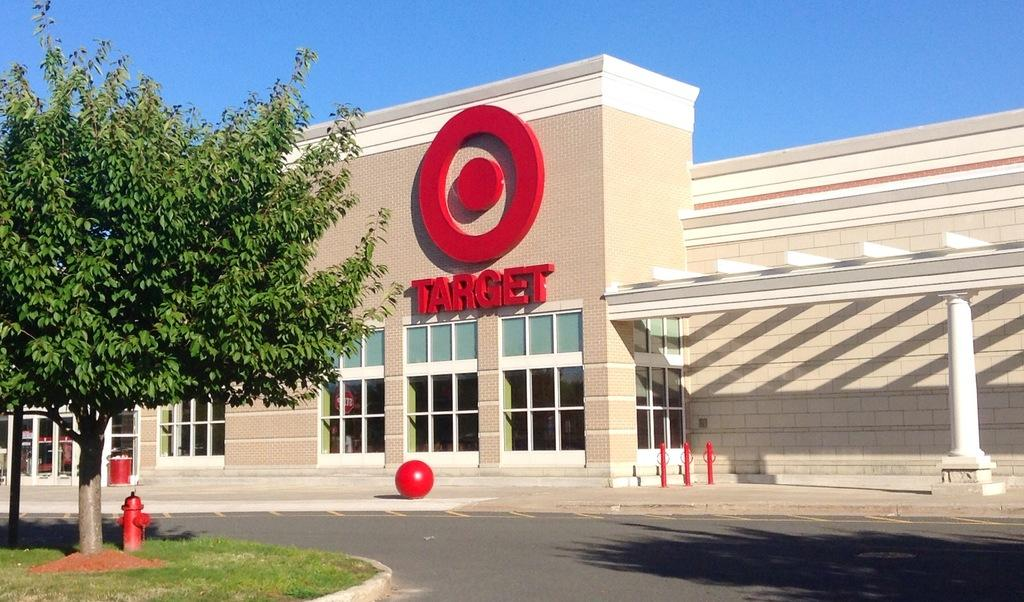What is located on the left side of the image? There is a tree on the left side of the image. What can be seen in the background of the image? There is a building with text in the background of the image. What is visible at the top of the image? The sky is visible at the top of the image. How many servants are standing near the tree in the image? There are no servants present in the image; it only features a tree, a building with text, and the sky. What type of twig can be seen falling from the tree in the image? There is no twig falling from the tree in the image; it only shows the tree, a building with text, and the sky. 